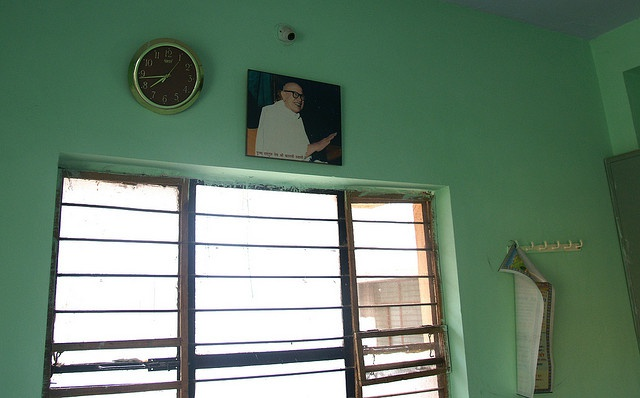Describe the objects in this image and their specific colors. I can see clock in darkgreen and black tones and people in darkgreen, gray, and black tones in this image. 